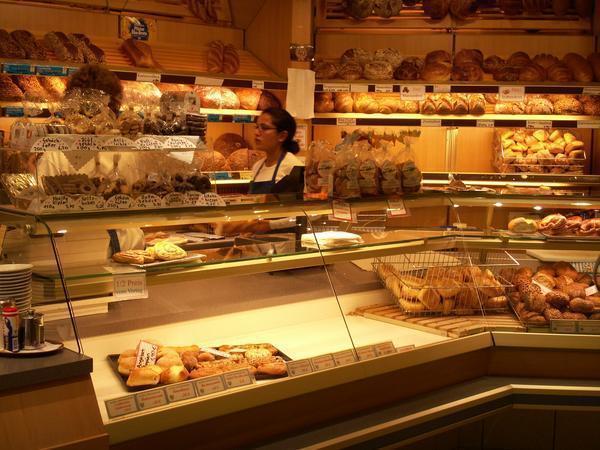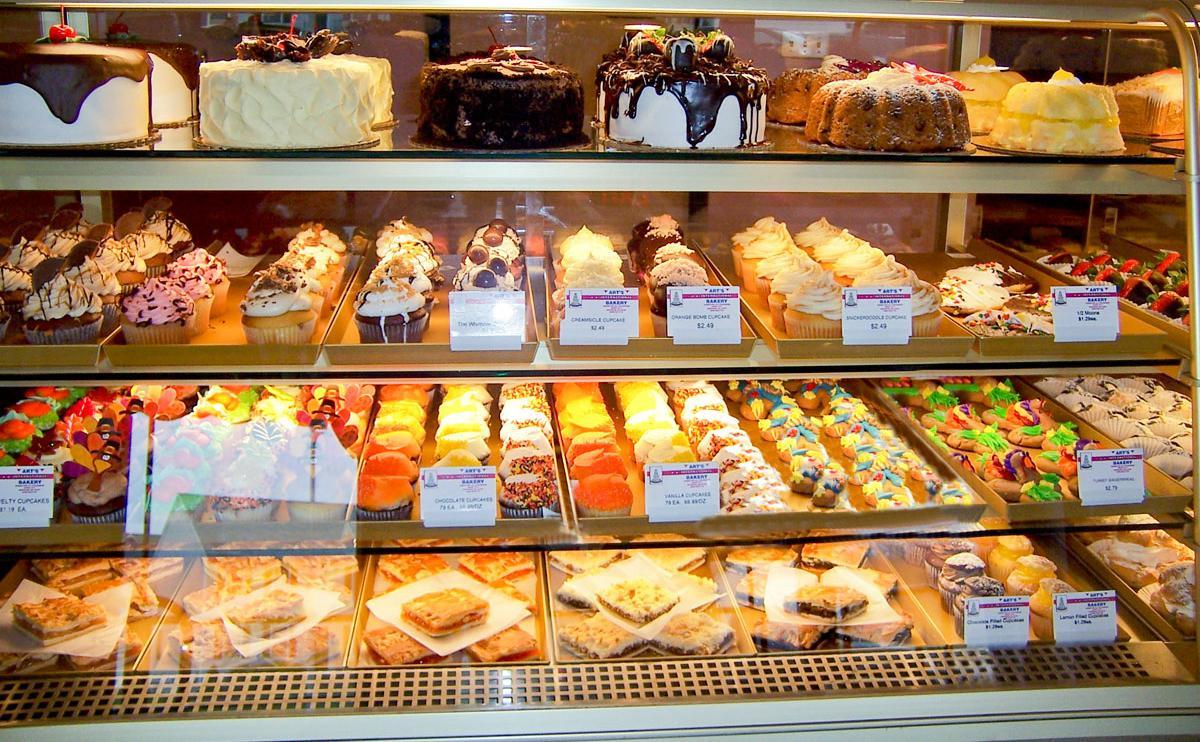The first image is the image on the left, the second image is the image on the right. Considering the images on both sides, is "A sign announces the name of the bakery in the image on the right." valid? Answer yes or no. No. The first image is the image on the left, the second image is the image on the right. Given the left and right images, does the statement "One female worker with a white top and no hat is behind a glass display case that turns a corner, in one image." hold true? Answer yes or no. Yes. 